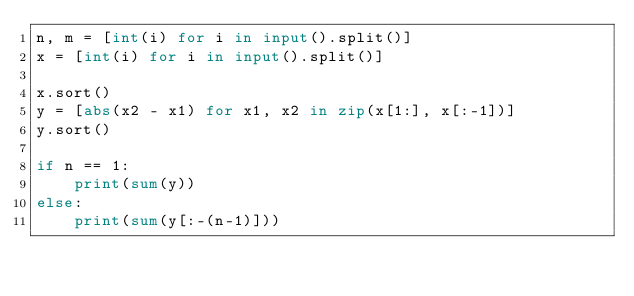<code> <loc_0><loc_0><loc_500><loc_500><_Python_>n, m = [int(i) for i in input().split()]
x = [int(i) for i in input().split()]

x.sort()
y = [abs(x2 - x1) for x1, x2 in zip(x[1:], x[:-1])]
y.sort()

if n == 1:
    print(sum(y))
else:
    print(sum(y[:-(n-1)]))</code> 